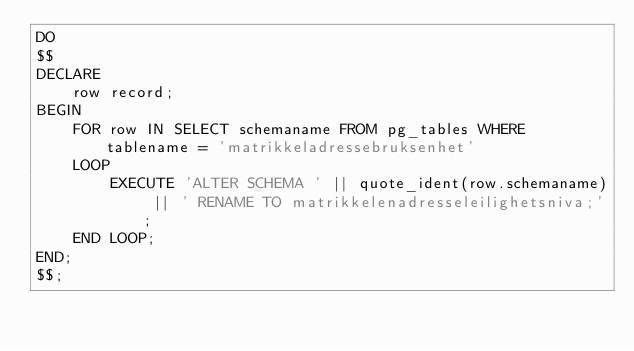Convert code to text. <code><loc_0><loc_0><loc_500><loc_500><_SQL_>DO
$$
DECLARE
    row record;
BEGIN
    FOR row IN SELECT schemaname FROM pg_tables WHERE tablename = 'matrikkeladressebruksenhet'
    LOOP
        EXECUTE 'ALTER SCHEMA ' || quote_ident(row.schemaname) || ' RENAME TO matrikkelenadresseleilighetsniva;';
    END LOOP;
END;
$$;
</code> 